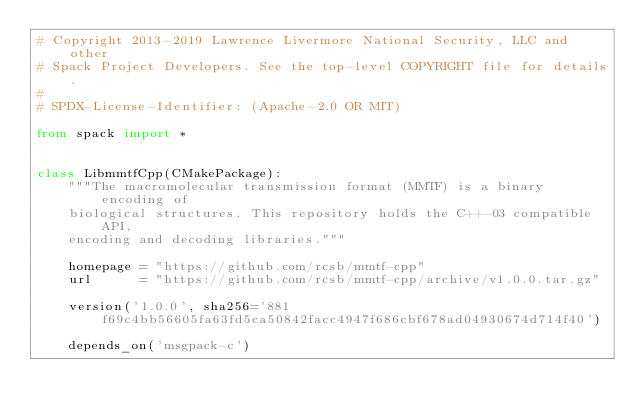<code> <loc_0><loc_0><loc_500><loc_500><_Python_># Copyright 2013-2019 Lawrence Livermore National Security, LLC and other
# Spack Project Developers. See the top-level COPYRIGHT file for details.
#
# SPDX-License-Identifier: (Apache-2.0 OR MIT)

from spack import *


class LibmmtfCpp(CMakePackage):
    """The macromolecular transmission format (MMTF) is a binary encoding of
    biological structures. This repository holds the C++-03 compatible API,
    encoding and decoding libraries."""

    homepage = "https://github.com/rcsb/mmtf-cpp"
    url      = "https://github.com/rcsb/mmtf-cpp/archive/v1.0.0.tar.gz"

    version('1.0.0', sha256='881f69c4bb56605fa63fd5ca50842facc4947f686cbf678ad04930674d714f40')

    depends_on('msgpack-c')
</code> 